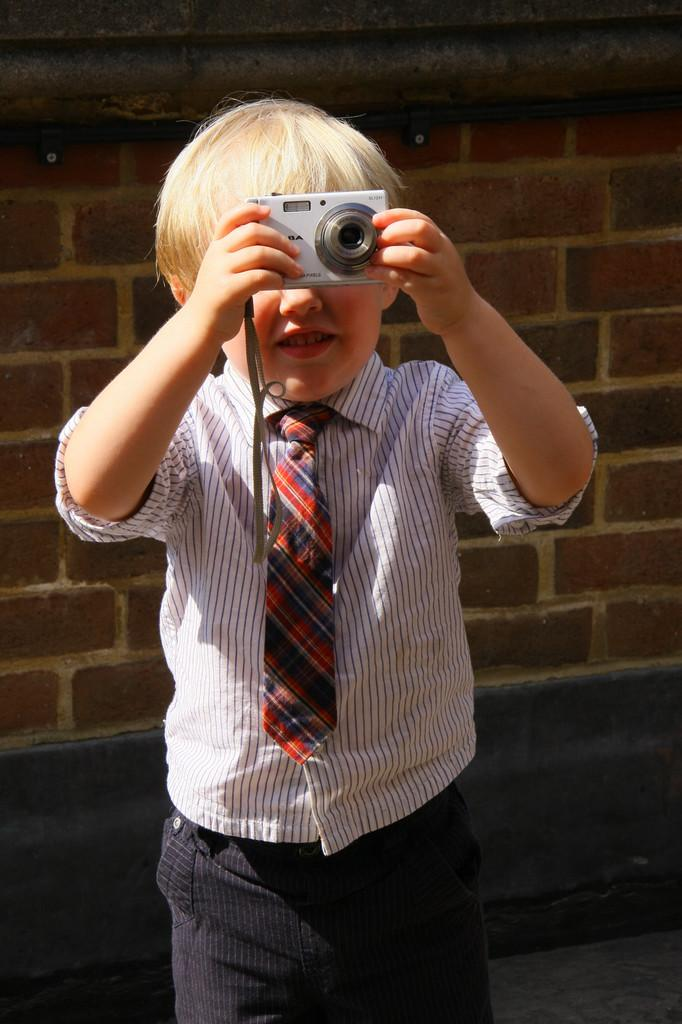Who is the main subject in the picture? The main subject in the picture is a small boy. What is the boy wearing? The boy is wearing a white and black striped shirt with a red tie. What is the boy holding in his hand? The boy is holding a camera in his hand. What is the boy doing with the camera? The boy is taking a photo. What type of silk material is used to make the boy's shirt in the image? There is no mention of silk material in the description of the boy's shirt. The shirt is described as having white and black stripes with a red tie. 